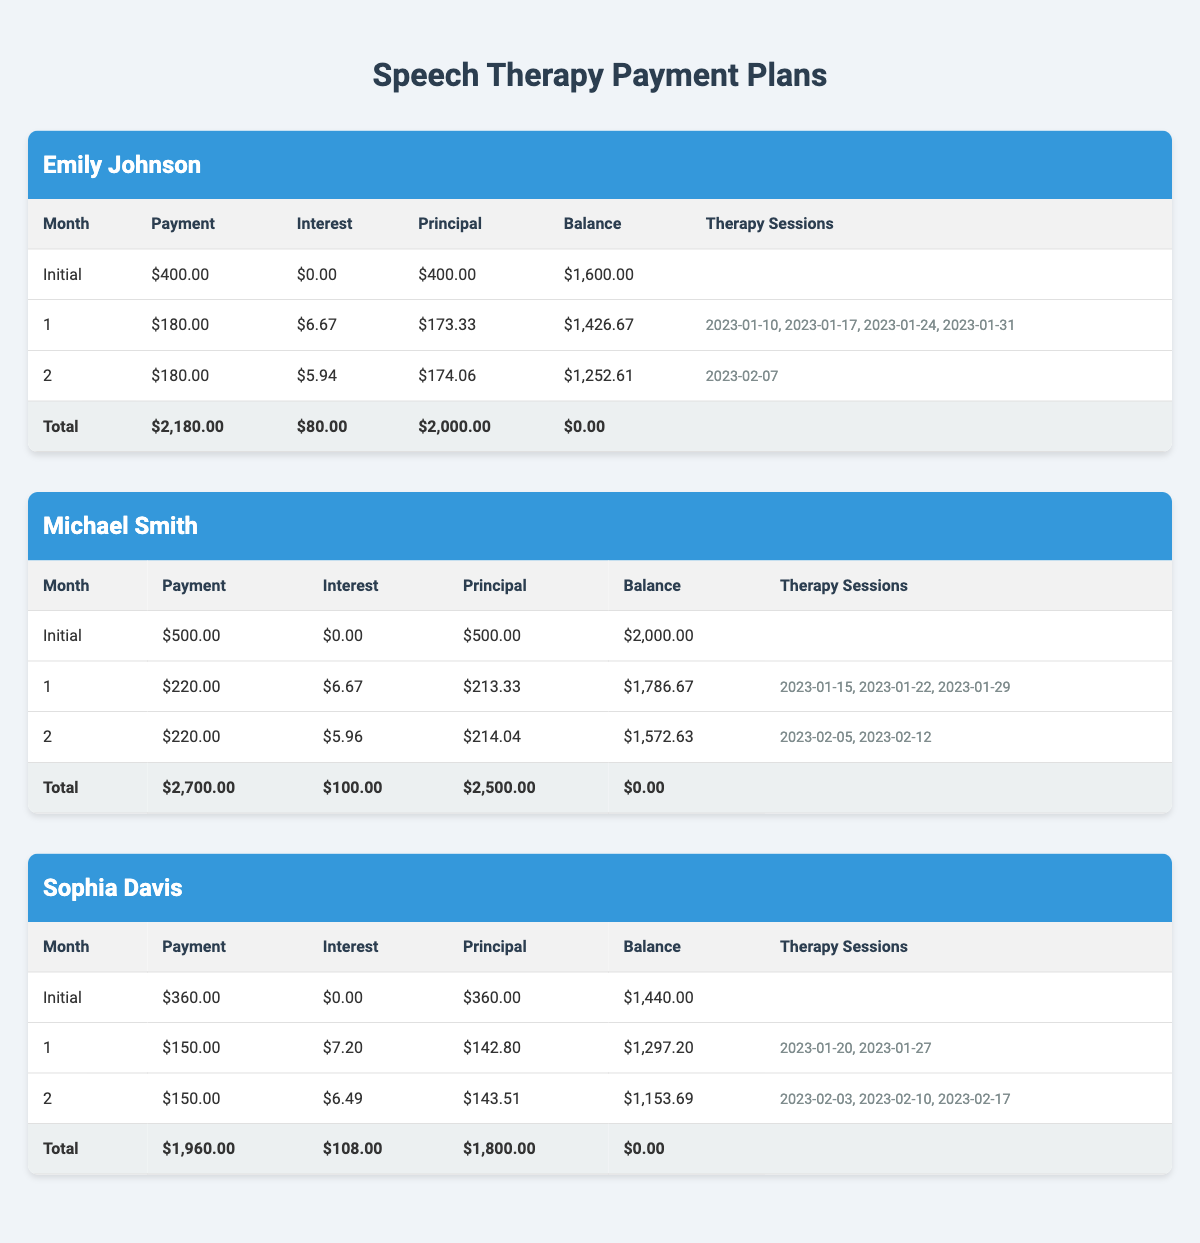What is the total cost of Emily Johnson's treatment plan? The total cost of Emily Johnson's treatment plan is listed as $2000 in the table under "treatmentPlanCost".
Answer: 2000 How much is Michael Smith's initial payment? Michael Smith's initial payment is displayed as $500.00 in the "Initial" row of his table.
Answer: 500 What is the remaining balance for Sophia Davis after two months? In Sophia Davis's table, after the "Initial" payment of $360.00 and two monthly payments of $150.00 each, the balance after two months is calculated as $1,440.00 - ($150.00 + $150.00) = $1,140.00.
Answer: 1140 Did Emily Johnson make payments in the first month? Yes, Emily Johnson made a payment of $180.00 in the first month, as shown in the table.
Answer: Yes What was the average monthly payment for Michael Smith? Michael Smith's total monthly payments are $220.00 for 10 months, leading to an average monthly payment of $220.00 as it is the same monthly payment throughout the term.
Answer: 220 How much total interest did Sophia Davis pay by the end of her plan? Sophia Davis paid a total interest of $108.00, which is listed in the last row of her table under the "Total" column for interest paid.
Answer: 108 What is the difference between the total payments made by Emily Johnson and Michael Smith? The total payments for Emily Johnson amount to $2,180.00, while for Michael Smith, they sum up to $2,700.00. The difference is calculated as $2,700.00 - $2,180.00 = $520.00.
Answer: 520 How many therapy sessions did Michael Smith have in total? Michael Smith had a total of 5 therapy sessions, as indicated by the dates accumulated in the "Therapy Sessions" columns in his table.
Answer: 5 What is the highest monthly payment amount among the three patients? The highest monthly payment across the patients is Michael Smith's $220.00, found in the monthly payment section of the tables compared with others.
Answer: 220 